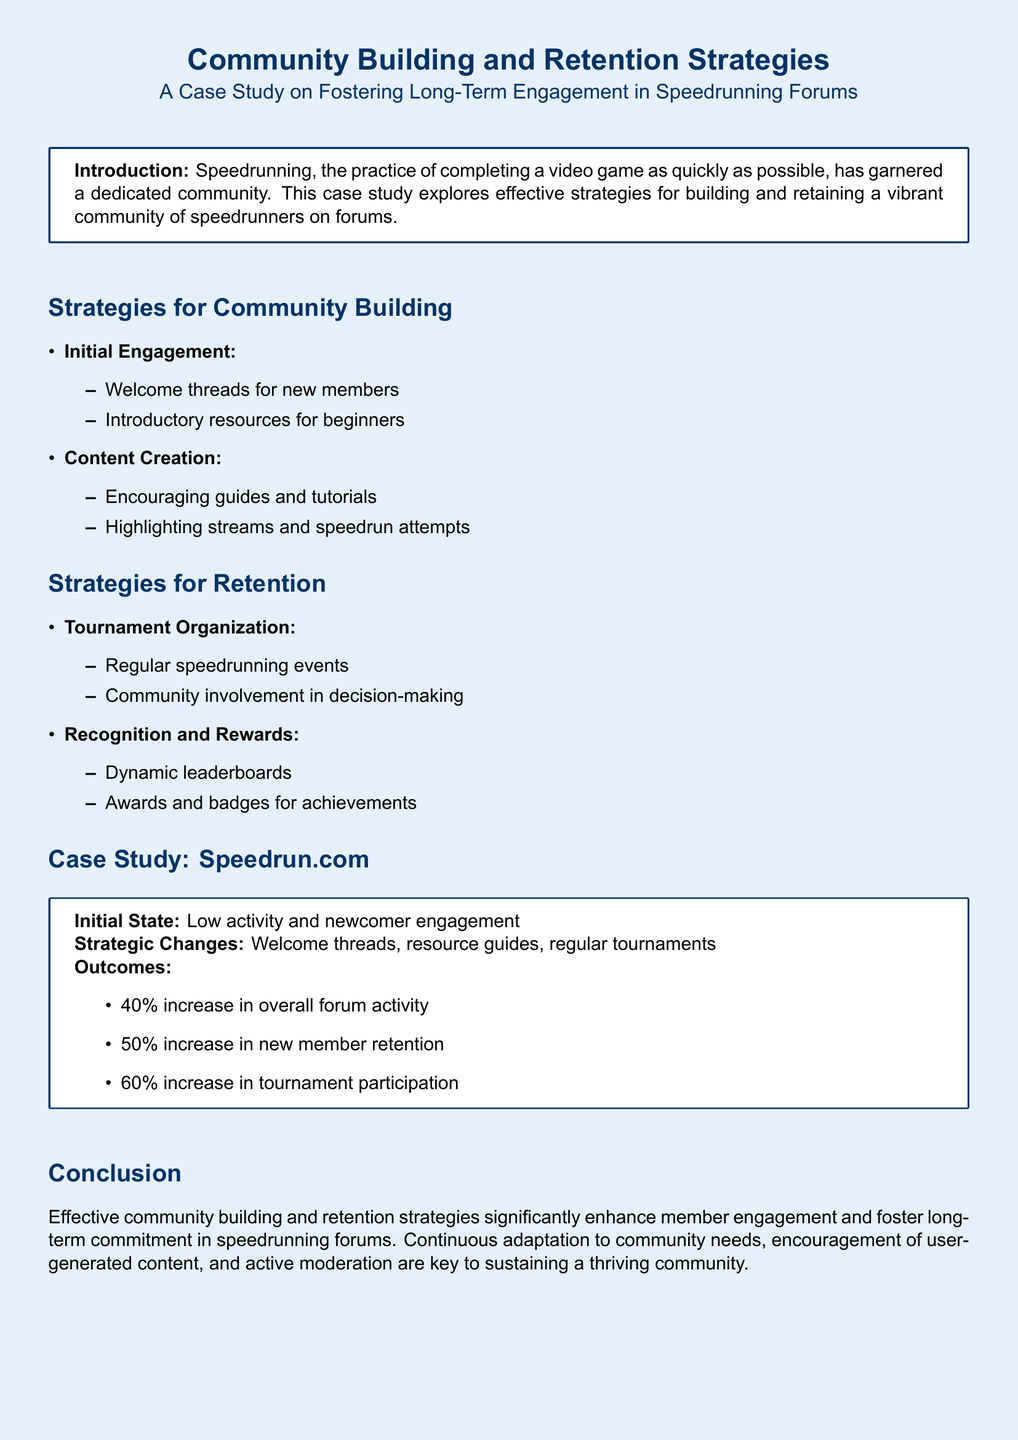What are the two main strategies for community building? The strategies listed under community building are initial engagement and content creation.
Answer: Initial engagement, Content creation What was the percentage increase in new member retention? The case study states that there was a 50% increase in new member retention after implementing strategic changes.
Answer: 50% What are two methods for recognizing community achievements? The document lists dynamic leaderboards and awards and badges as methods for recognition.
Answer: Dynamic leaderboards, Awards and badges What specific change contributed to a 40% increase in forum activity? The introduction of welcome threads, resource guides, and regular tournaments were strategic changes that led to increased activity.
Answer: Welcome threads, resource guides, regular tournaments What is the focus of the case study presented in the document? The case study focuses on fostering long-term engagement in speedrunning forums.
Answer: Fostering long-term engagement in speedrunning forums How are tournaments described in the retention strategies? Tournaments are described as regular speedrunning events that involve community decision-making.
Answer: Regular speedrunning events, Community involvement in decision-making What color theme is used in the document? The document features a light blue color theme for its background and a dark blue for its text.
Answer: Light blue, Dark blue What is the purpose of welcome threads mentioned in the document? Welcome threads are aimed at engaging new members as part of initial engagement strategies.
Answer: Engaging new members 